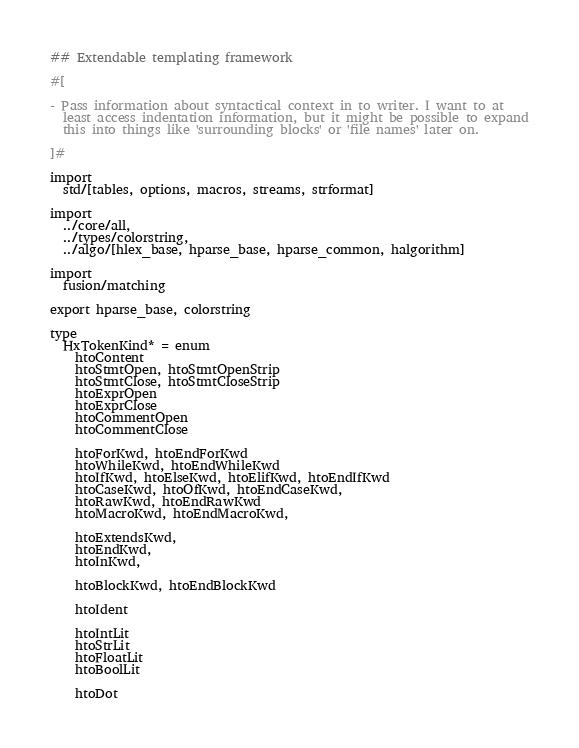Convert code to text. <code><loc_0><loc_0><loc_500><loc_500><_Nim_>## Extendable templating framework

#[

- Pass information about syntactical context in to writer. I want to at
  least access indentation information, but it might be possible to expand
  this into things like 'surrounding blocks' or 'file names' later on.

]#

import
  std/[tables, options, macros, streams, strformat]

import
  ../core/all,
  ../types/colorstring,
  ../algo/[hlex_base, hparse_base, hparse_common, halgorithm]

import
  fusion/matching

export hparse_base, colorstring

type
  HxTokenKind* = enum
    htoContent
    htoStmtOpen, htoStmtOpenStrip
    htoStmtClose, htoStmtCloseStrip
    htoExprOpen
    htoExprClose
    htoCommentOpen
    htoCommentClose

    htoForKwd, htoEndForKwd
    htoWhileKwd, htoEndWhileKwd
    htoIfKwd, htoElseKwd, htoElifKwd, htoEndIfKwd
    htoCaseKwd, htoOfKwd, htoEndCaseKwd,
    htoRawKwd, htoEndRawKwd
    htoMacroKwd, htoEndMacroKwd,

    htoExtendsKwd,
    htoEndKwd,
    htoInKwd,

    htoBlockKwd, htoEndBlockKwd

    htoIdent

    htoIntLit
    htoStrLit
    htoFloatLit
    htoBoolLit

    htoDot</code> 